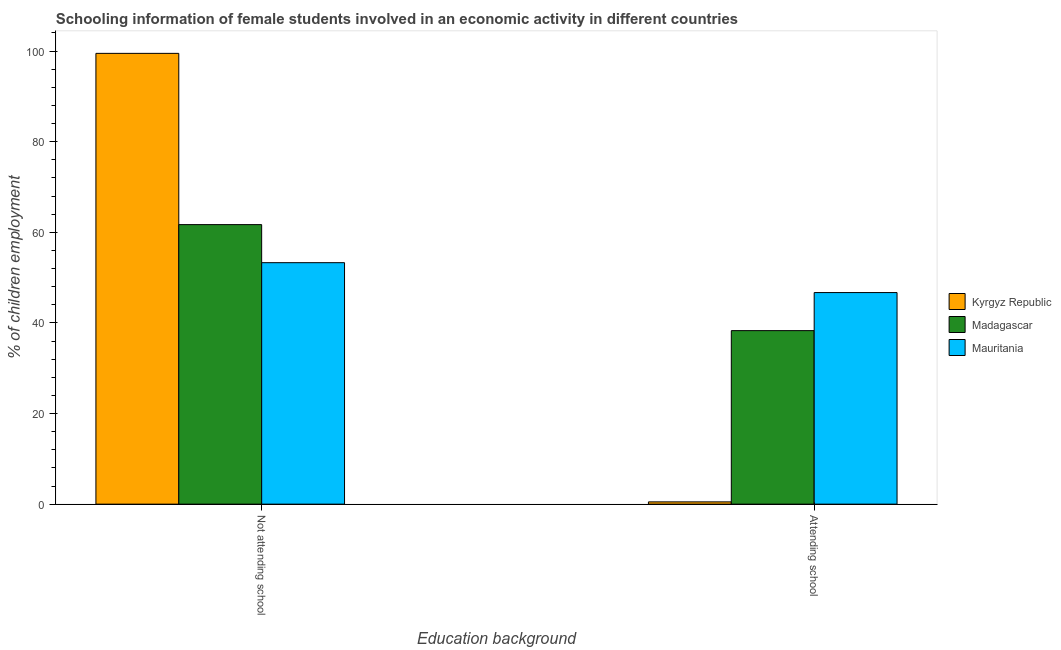Are the number of bars per tick equal to the number of legend labels?
Give a very brief answer. Yes. Are the number of bars on each tick of the X-axis equal?
Offer a very short reply. Yes. How many bars are there on the 1st tick from the right?
Your answer should be compact. 3. What is the label of the 2nd group of bars from the left?
Make the answer very short. Attending school. Across all countries, what is the maximum percentage of employed females who are attending school?
Your response must be concise. 46.7. Across all countries, what is the minimum percentage of employed females who are attending school?
Keep it short and to the point. 0.5. In which country was the percentage of employed females who are not attending school maximum?
Make the answer very short. Kyrgyz Republic. In which country was the percentage of employed females who are not attending school minimum?
Your answer should be very brief. Mauritania. What is the total percentage of employed females who are attending school in the graph?
Ensure brevity in your answer.  85.5. What is the difference between the percentage of employed females who are not attending school in Kyrgyz Republic and that in Madagascar?
Make the answer very short. 37.8. What is the difference between the percentage of employed females who are not attending school in Madagascar and the percentage of employed females who are attending school in Kyrgyz Republic?
Provide a succinct answer. 61.2. What is the difference between the percentage of employed females who are attending school and percentage of employed females who are not attending school in Madagascar?
Offer a terse response. -23.4. What is the ratio of the percentage of employed females who are attending school in Kyrgyz Republic to that in Madagascar?
Ensure brevity in your answer.  0.01. Is the percentage of employed females who are attending school in Mauritania less than that in Madagascar?
Offer a very short reply. No. In how many countries, is the percentage of employed females who are not attending school greater than the average percentage of employed females who are not attending school taken over all countries?
Your answer should be very brief. 1. What does the 3rd bar from the left in Not attending school represents?
Make the answer very short. Mauritania. What does the 2nd bar from the right in Not attending school represents?
Your response must be concise. Madagascar. How many bars are there?
Provide a short and direct response. 6. How many countries are there in the graph?
Your answer should be compact. 3. What is the difference between two consecutive major ticks on the Y-axis?
Your answer should be very brief. 20. Are the values on the major ticks of Y-axis written in scientific E-notation?
Give a very brief answer. No. Does the graph contain any zero values?
Provide a succinct answer. No. Where does the legend appear in the graph?
Your answer should be very brief. Center right. How many legend labels are there?
Ensure brevity in your answer.  3. How are the legend labels stacked?
Ensure brevity in your answer.  Vertical. What is the title of the graph?
Your answer should be compact. Schooling information of female students involved in an economic activity in different countries. Does "Bulgaria" appear as one of the legend labels in the graph?
Your answer should be compact. No. What is the label or title of the X-axis?
Give a very brief answer. Education background. What is the label or title of the Y-axis?
Your response must be concise. % of children employment. What is the % of children employment in Kyrgyz Republic in Not attending school?
Make the answer very short. 99.5. What is the % of children employment in Madagascar in Not attending school?
Offer a terse response. 61.7. What is the % of children employment in Mauritania in Not attending school?
Offer a very short reply. 53.3. What is the % of children employment of Kyrgyz Republic in Attending school?
Provide a short and direct response. 0.5. What is the % of children employment of Madagascar in Attending school?
Your answer should be very brief. 38.3. What is the % of children employment of Mauritania in Attending school?
Make the answer very short. 46.7. Across all Education background, what is the maximum % of children employment of Kyrgyz Republic?
Provide a short and direct response. 99.5. Across all Education background, what is the maximum % of children employment of Madagascar?
Your answer should be very brief. 61.7. Across all Education background, what is the maximum % of children employment of Mauritania?
Give a very brief answer. 53.3. Across all Education background, what is the minimum % of children employment in Madagascar?
Give a very brief answer. 38.3. Across all Education background, what is the minimum % of children employment in Mauritania?
Ensure brevity in your answer.  46.7. What is the total % of children employment in Kyrgyz Republic in the graph?
Provide a short and direct response. 100. What is the total % of children employment in Mauritania in the graph?
Your response must be concise. 100. What is the difference between the % of children employment in Kyrgyz Republic in Not attending school and that in Attending school?
Your answer should be very brief. 99. What is the difference between the % of children employment of Madagascar in Not attending school and that in Attending school?
Your answer should be very brief. 23.4. What is the difference between the % of children employment of Kyrgyz Republic in Not attending school and the % of children employment of Madagascar in Attending school?
Your answer should be compact. 61.2. What is the difference between the % of children employment of Kyrgyz Republic in Not attending school and the % of children employment of Mauritania in Attending school?
Provide a succinct answer. 52.8. What is the difference between the % of children employment in Kyrgyz Republic and % of children employment in Madagascar in Not attending school?
Offer a terse response. 37.8. What is the difference between the % of children employment of Kyrgyz Republic and % of children employment of Mauritania in Not attending school?
Your answer should be compact. 46.2. What is the difference between the % of children employment of Kyrgyz Republic and % of children employment of Madagascar in Attending school?
Offer a very short reply. -37.8. What is the difference between the % of children employment of Kyrgyz Republic and % of children employment of Mauritania in Attending school?
Your answer should be very brief. -46.2. What is the difference between the % of children employment of Madagascar and % of children employment of Mauritania in Attending school?
Make the answer very short. -8.4. What is the ratio of the % of children employment of Kyrgyz Republic in Not attending school to that in Attending school?
Your answer should be very brief. 199. What is the ratio of the % of children employment in Madagascar in Not attending school to that in Attending school?
Your response must be concise. 1.61. What is the ratio of the % of children employment in Mauritania in Not attending school to that in Attending school?
Your answer should be compact. 1.14. What is the difference between the highest and the second highest % of children employment of Madagascar?
Offer a very short reply. 23.4. What is the difference between the highest and the second highest % of children employment in Mauritania?
Offer a very short reply. 6.6. What is the difference between the highest and the lowest % of children employment of Madagascar?
Ensure brevity in your answer.  23.4. 